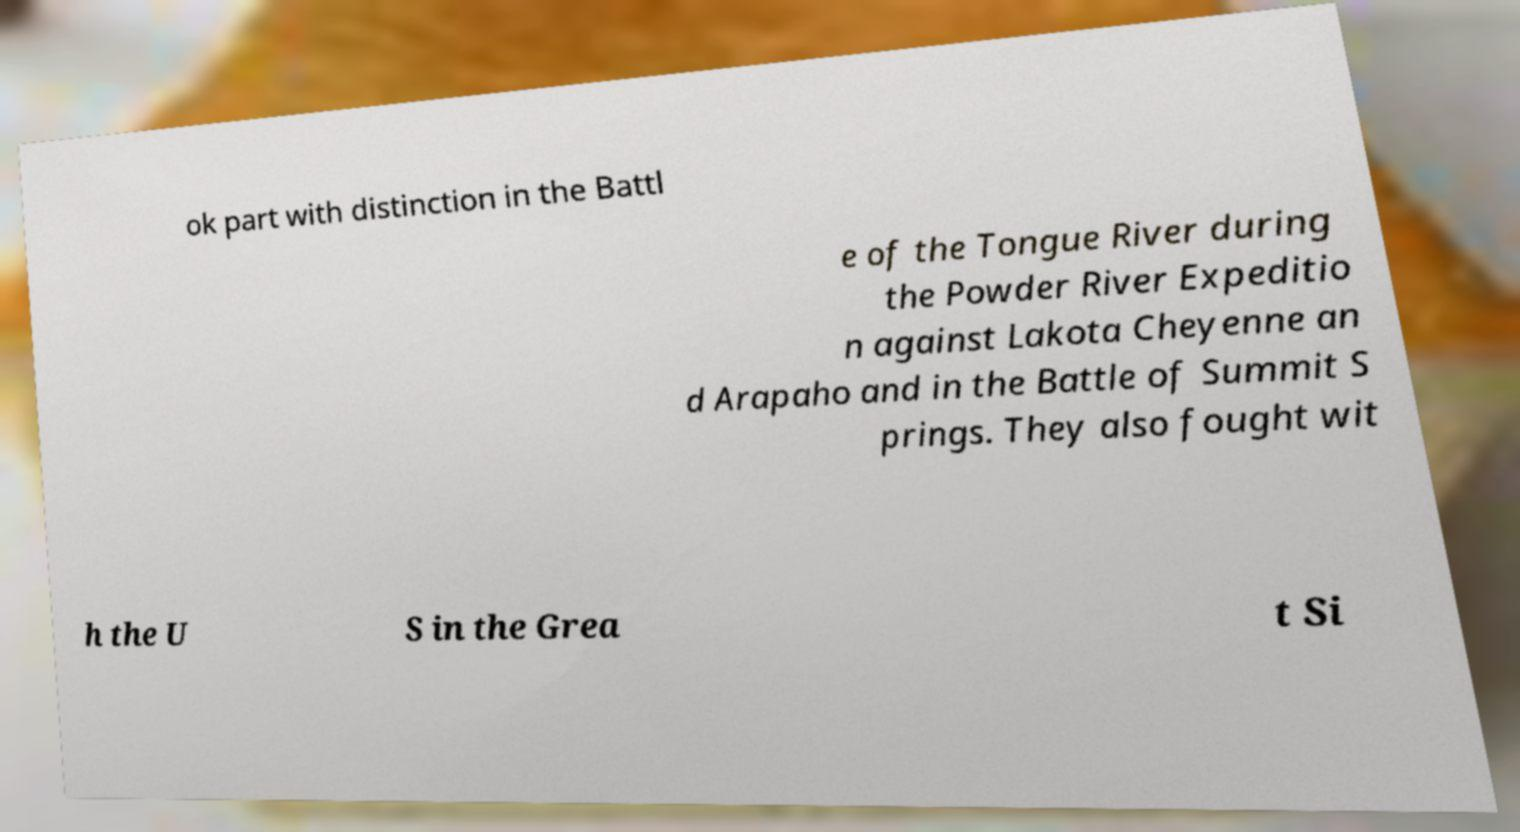I need the written content from this picture converted into text. Can you do that? ok part with distinction in the Battl e of the Tongue River during the Powder River Expeditio n against Lakota Cheyenne an d Arapaho and in the Battle of Summit S prings. They also fought wit h the U S in the Grea t Si 